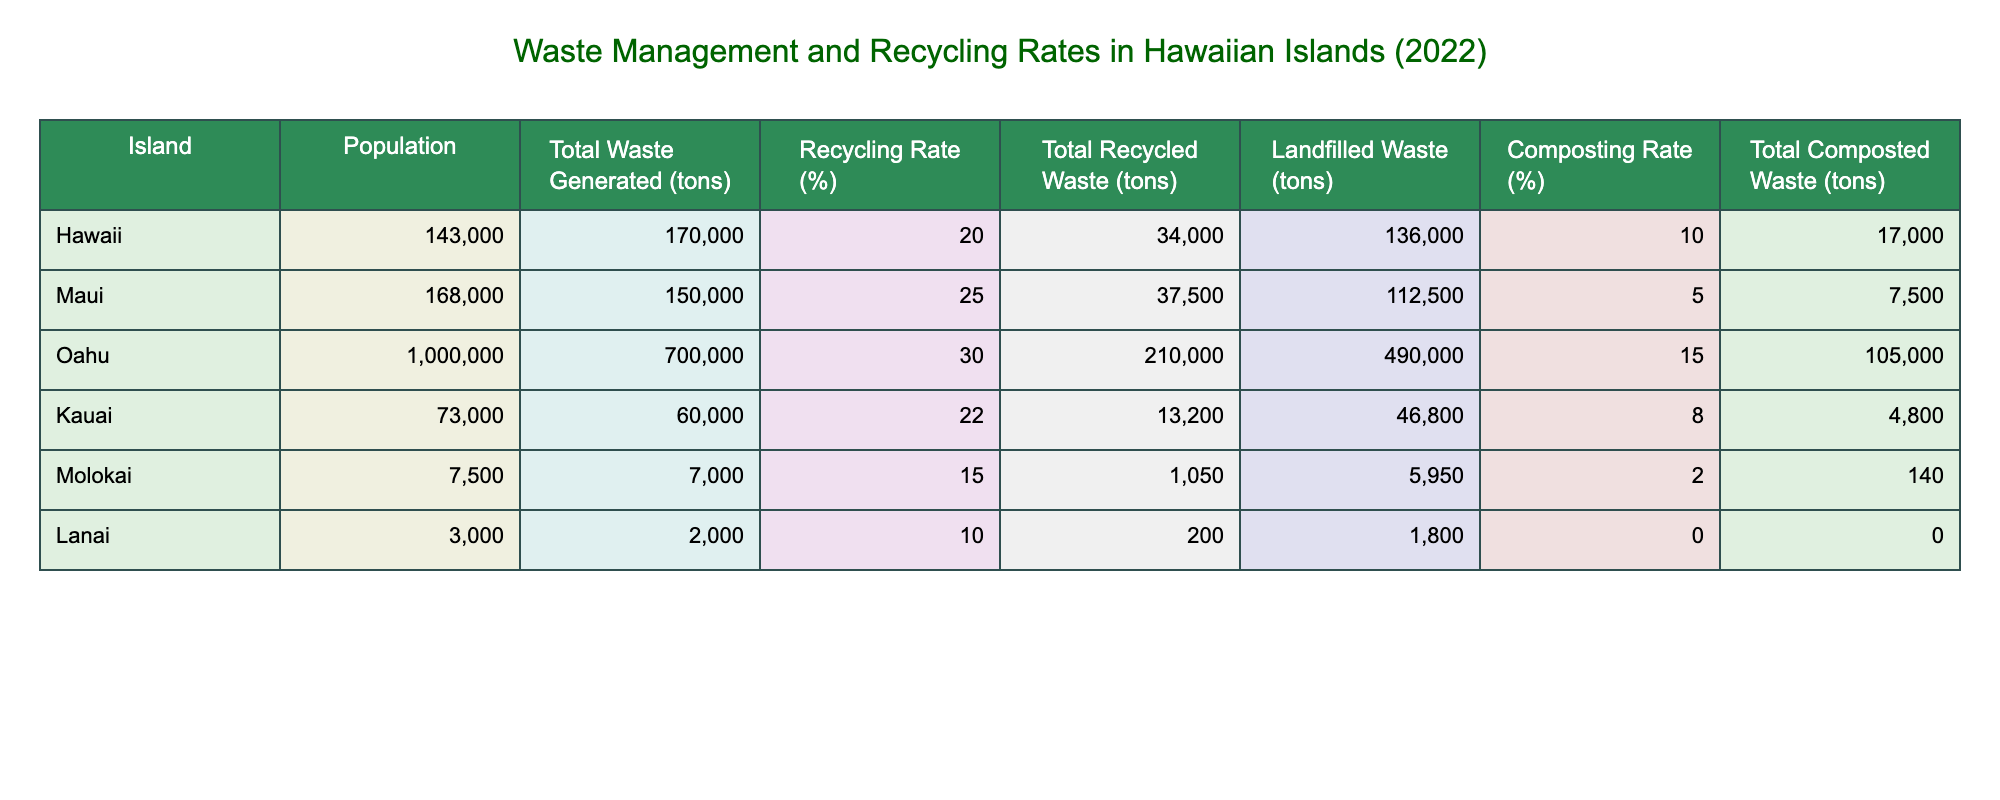What is the recycling rate for the island of Oahu? The table shows that the recycling rate for Oahu is 30%.
Answer: 30% Which island generated the most total waste in tons? From the table, Oahu generated the most total waste at 700,000 tons.
Answer: Oahu What is the total recycled waste for Maui? The table indicates that Maui's total recycled waste is 37,500 tons.
Answer: 37,500 tons Is the composting rate on Lanai greater than that on Molokai? The table lists Lanai's composting rate as 0% and Molokai's as 2%, so the statement is false.
Answer: No What is the total amount of landfilled waste across all Hawaiian islands? By summing the landfilled waste for each island: 136,000 (Hawaii) + 112,500 (Maui) + 490,000 (Oahu) + 46,800 (Kauai) + 5,950 (Molokai) + 1,800 (Lanai) = 792,050 tons.
Answer: 792,050 tons If we average the recycling rates of all the islands, what do we get? To find the average, sum the recycling rates: (20 + 25 + 30 + 22 + 15 + 10) = 122 and divide by 6 to get 20.33%.
Answer: 20.33% For which island is the total composted waste the lowest? The table shows that Lanai has the lowest total composted waste at 0 tons.
Answer: Lanai What percentage of the total waste generated on the island of Kauai was recycled? Kauai generated 60,000 tons of waste and recycled 13,200 tons. To find the percentage, (13,200/60,000) * 100 = 22%.
Answer: 22% Is the population on Maui greater than the combined total of the populations of Molokai and Lanai? Maui's population is 168,000. Molokai has 7,500 and Lanai has 3,000, totaling 10,500. Since 168,000 > 10,500, the statement is true.
Answer: Yes 